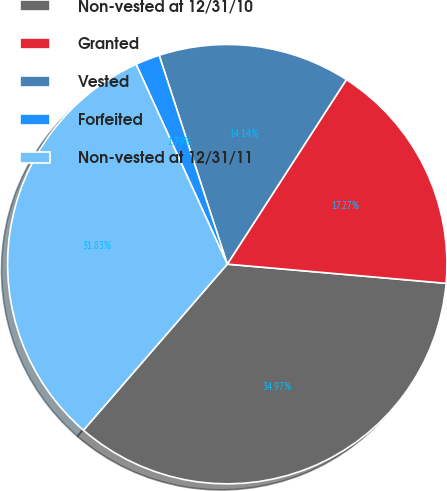<chart> <loc_0><loc_0><loc_500><loc_500><pie_chart><fcel>Non-vested at 12/31/10<fcel>Granted<fcel>Vested<fcel>Forfeited<fcel>Non-vested at 12/31/11<nl><fcel>34.97%<fcel>17.27%<fcel>14.14%<fcel>1.79%<fcel>31.83%<nl></chart> 